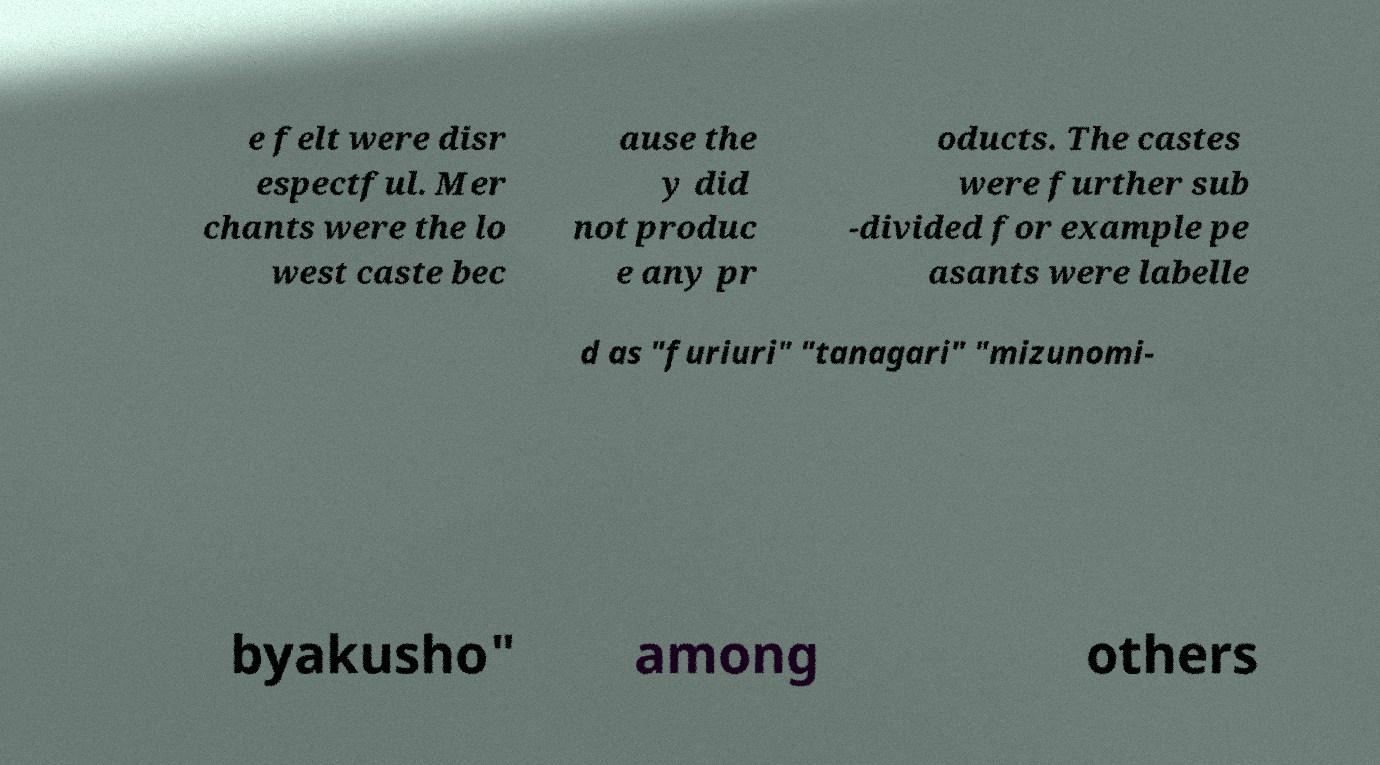Could you assist in decoding the text presented in this image and type it out clearly? e felt were disr espectful. Mer chants were the lo west caste bec ause the y did not produc e any pr oducts. The castes were further sub -divided for example pe asants were labelle d as "furiuri" "tanagari" "mizunomi- byakusho" among others 